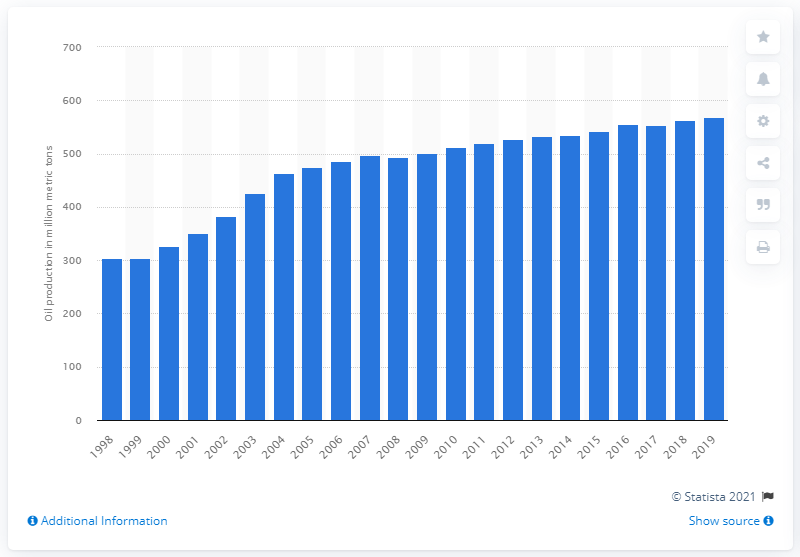Identify some key points in this picture. The Russian oil production in 2019 was 568.1. 